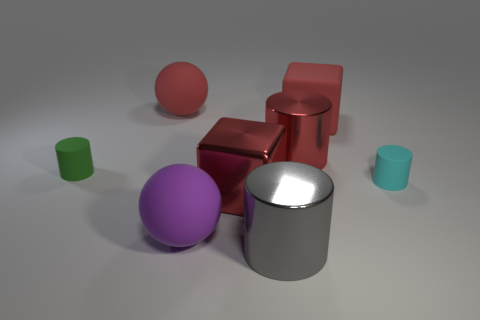Does the rubber cube have the same color as the rubber cylinder that is to the left of the red shiny cylinder?
Your answer should be very brief. No. What is the size of the cube that is made of the same material as the cyan cylinder?
Your response must be concise. Large. Are there any small shiny blocks of the same color as the large matte cube?
Make the answer very short. No. How many objects are either large shiny cylinders behind the gray metallic cylinder or small yellow cylinders?
Give a very brief answer. 1. Are the red cylinder and the block that is behind the red shiny cylinder made of the same material?
Your answer should be very brief. No. What size is the shiny cube that is the same color as the large matte block?
Provide a short and direct response. Large. Is there a big purple object made of the same material as the large gray object?
Ensure brevity in your answer.  No. How many things are either cylinders that are in front of the red shiny cube or spheres behind the red cylinder?
Keep it short and to the point. 2. There is a small cyan thing; does it have the same shape as the small matte thing that is left of the red shiny cylinder?
Your answer should be compact. Yes. How many other objects are there of the same shape as the purple thing?
Your answer should be compact. 1. 